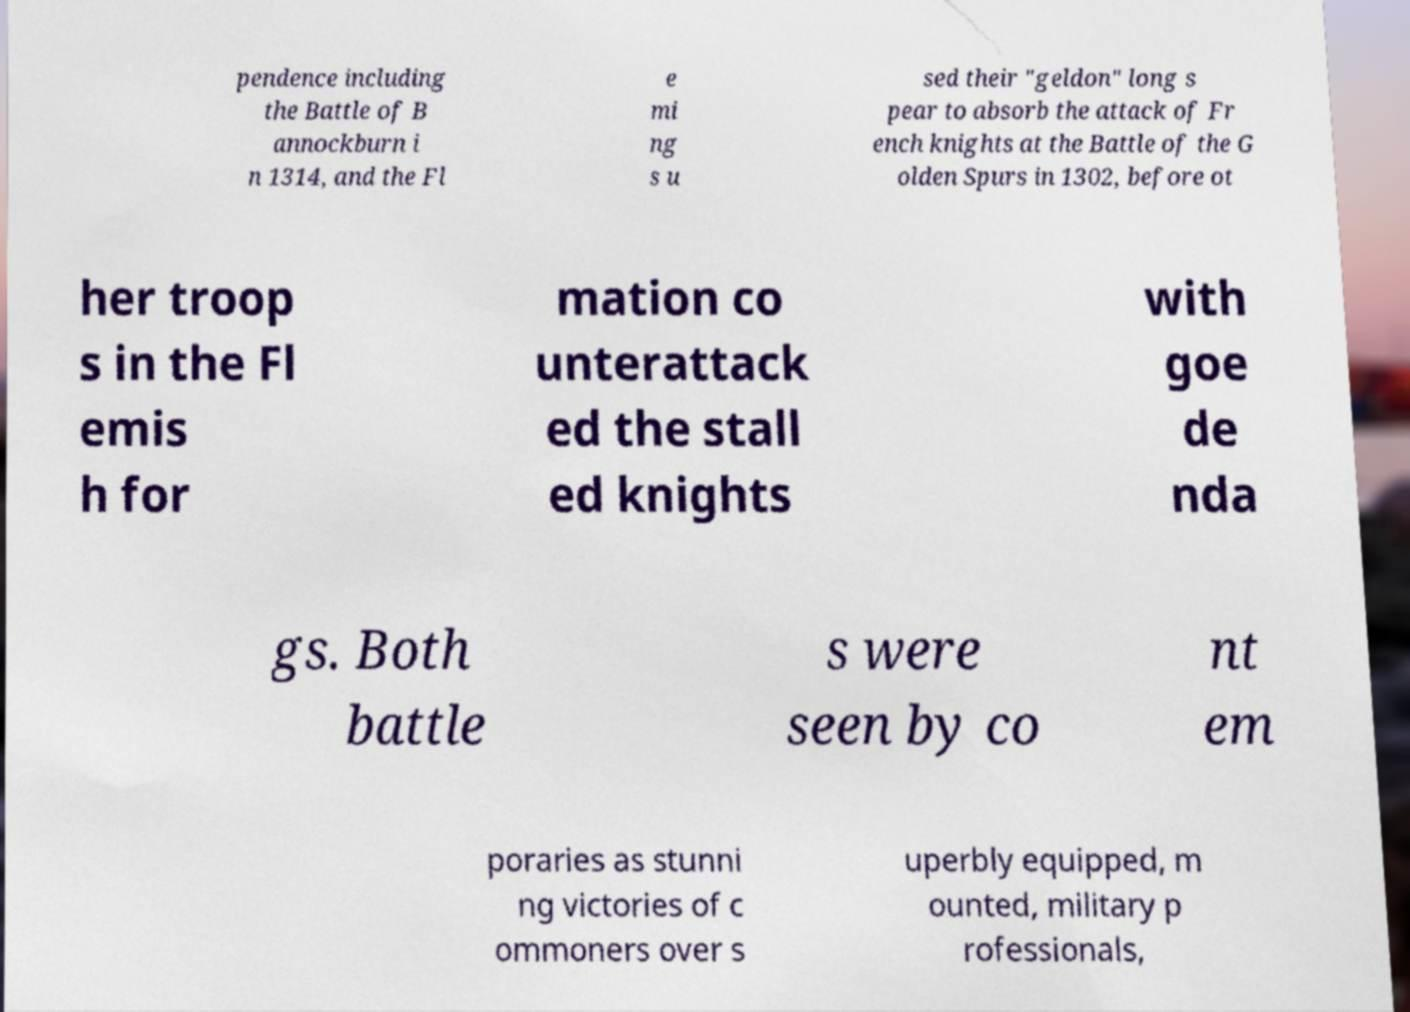Could you extract and type out the text from this image? pendence including the Battle of B annockburn i n 1314, and the Fl e mi ng s u sed their "geldon" long s pear to absorb the attack of Fr ench knights at the Battle of the G olden Spurs in 1302, before ot her troop s in the Fl emis h for mation co unterattack ed the stall ed knights with goe de nda gs. Both battle s were seen by co nt em poraries as stunni ng victories of c ommoners over s uperbly equipped, m ounted, military p rofessionals, 